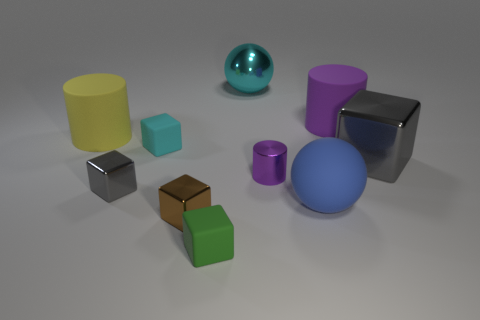What color is the metallic cylinder?
Make the answer very short. Purple. There is a purple thing that is on the left side of the blue rubber object; what material is it?
Your response must be concise. Metal. Are there an equal number of small gray blocks on the right side of the cyan rubber thing and shiny cylinders?
Keep it short and to the point. No. Do the green object and the brown metallic object have the same shape?
Ensure brevity in your answer.  Yes. Is there anything else of the same color as the tiny cylinder?
Make the answer very short. Yes. There is a big matte thing that is to the right of the shiny cylinder and behind the big gray block; what is its shape?
Offer a very short reply. Cylinder. Are there the same number of small brown objects behind the big gray object and purple rubber objects that are on the right side of the small gray metal block?
Your answer should be compact. No. How many balls are either small cyan things or red objects?
Ensure brevity in your answer.  0. What number of cyan blocks are made of the same material as the large cyan ball?
Make the answer very short. 0. There is a metallic object that is the same color as the large cube; what shape is it?
Ensure brevity in your answer.  Cube. 